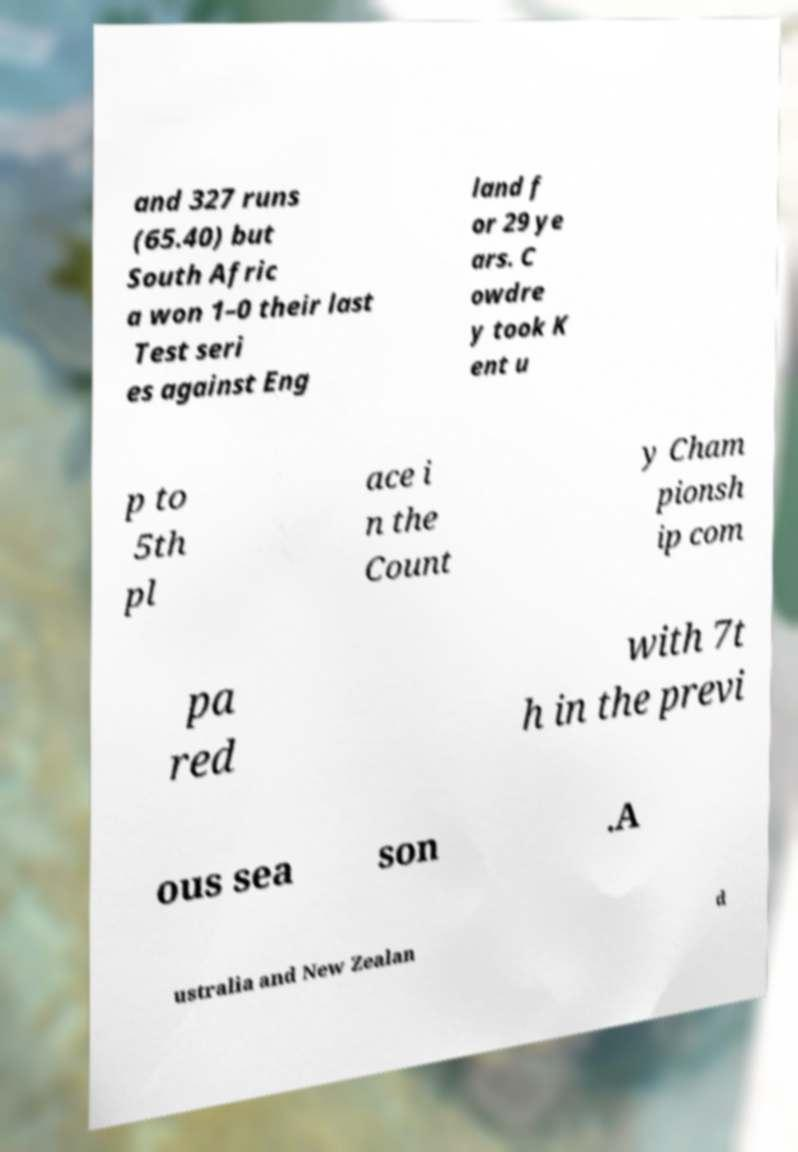What messages or text are displayed in this image? I need them in a readable, typed format. and 327 runs (65.40) but South Afric a won 1–0 their last Test seri es against Eng land f or 29 ye ars. C owdre y took K ent u p to 5th pl ace i n the Count y Cham pionsh ip com pa red with 7t h in the previ ous sea son .A ustralia and New Zealan d 